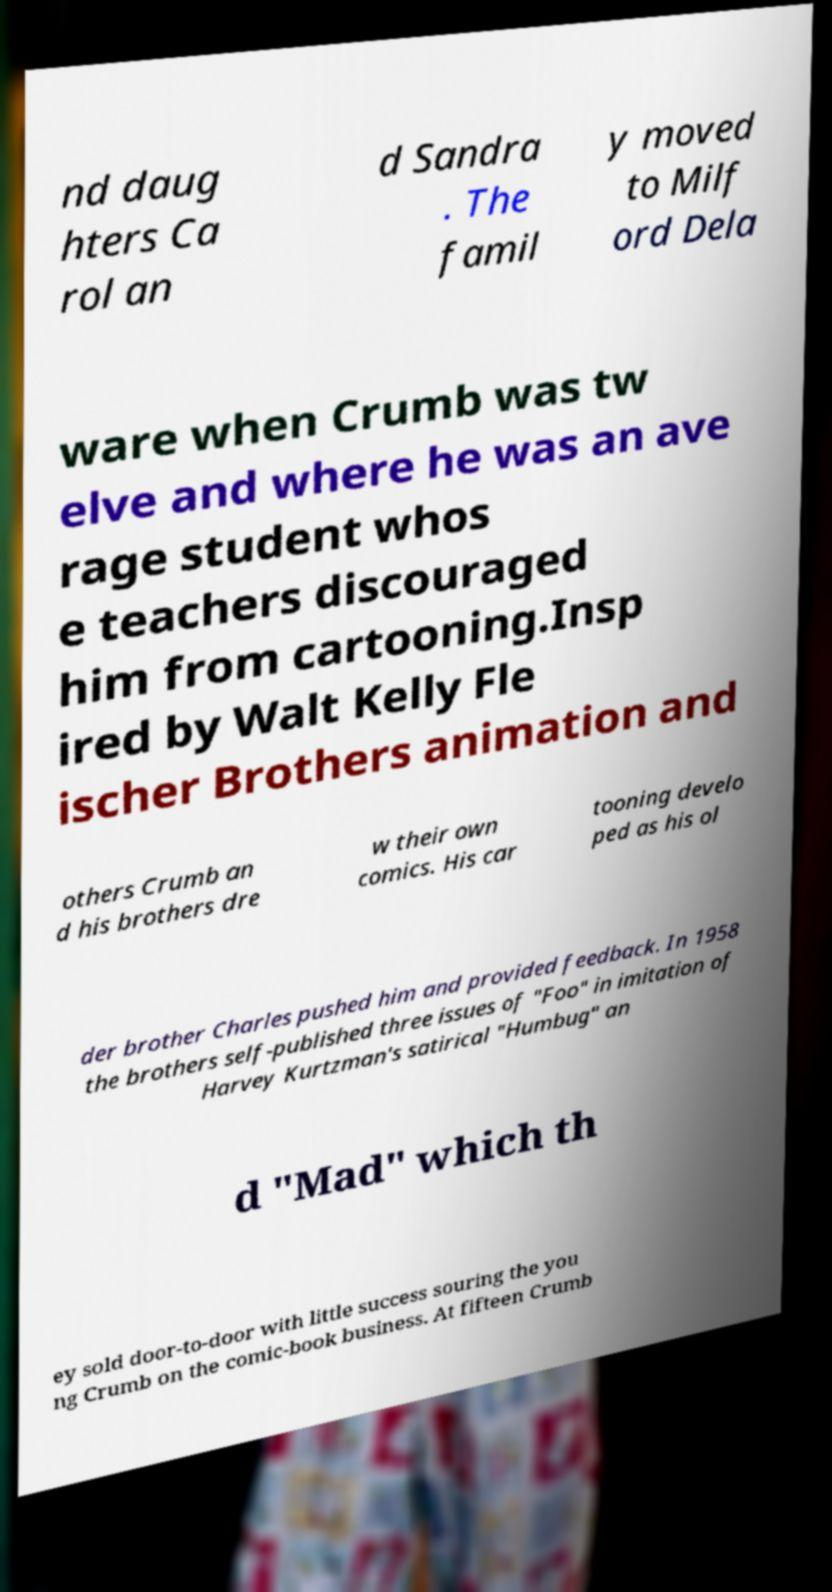Can you accurately transcribe the text from the provided image for me? nd daug hters Ca rol an d Sandra . The famil y moved to Milf ord Dela ware when Crumb was tw elve and where he was an ave rage student whos e teachers discouraged him from cartooning.Insp ired by Walt Kelly Fle ischer Brothers animation and others Crumb an d his brothers dre w their own comics. His car tooning develo ped as his ol der brother Charles pushed him and provided feedback. In 1958 the brothers self-published three issues of "Foo" in imitation of Harvey Kurtzman's satirical "Humbug" an d "Mad" which th ey sold door-to-door with little success souring the you ng Crumb on the comic-book business. At fifteen Crumb 